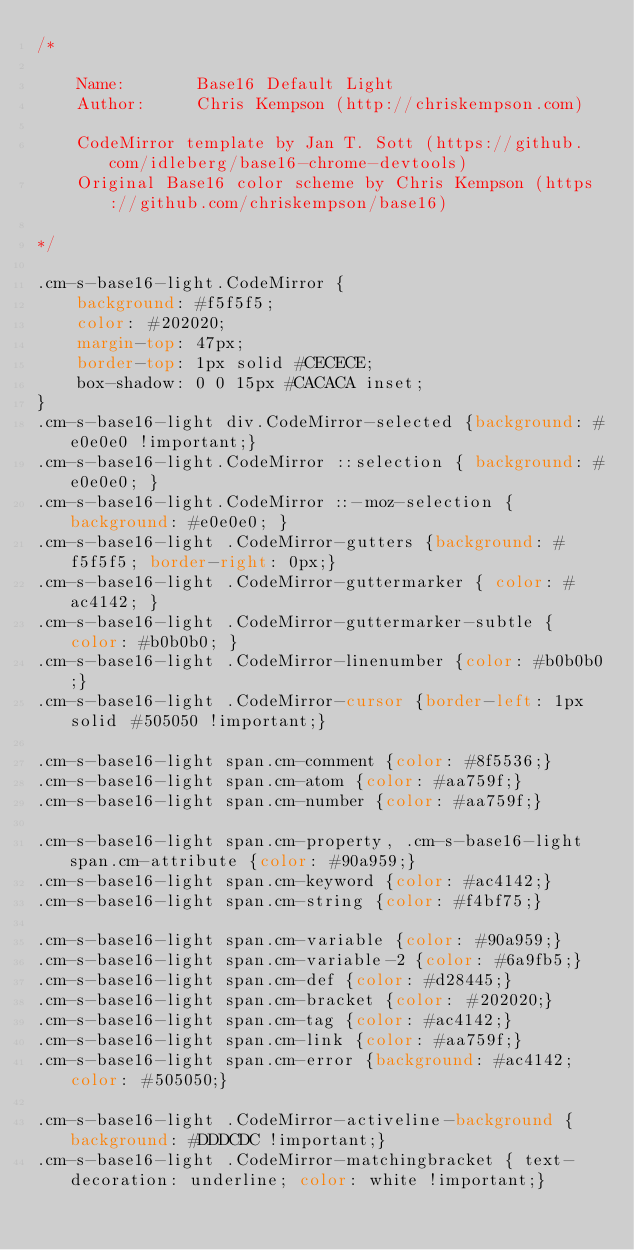<code> <loc_0><loc_0><loc_500><loc_500><_CSS_>/*

    Name:       Base16 Default Light
    Author:     Chris Kempson (http://chriskempson.com)

    CodeMirror template by Jan T. Sott (https://github.com/idleberg/base16-chrome-devtools)
    Original Base16 color scheme by Chris Kempson (https://github.com/chriskempson/base16)

*/

.cm-s-base16-light.CodeMirror {
    background: #f5f5f5;
    color: #202020;
    margin-top: 47px;
    border-top: 1px solid #CECECE;
    box-shadow: 0 0 15px #CACACA inset;
}
.cm-s-base16-light div.CodeMirror-selected {background: #e0e0e0 !important;}
.cm-s-base16-light.CodeMirror ::selection { background: #e0e0e0; }
.cm-s-base16-light.CodeMirror ::-moz-selection { background: #e0e0e0; }
.cm-s-base16-light .CodeMirror-gutters {background: #f5f5f5; border-right: 0px;}
.cm-s-base16-light .CodeMirror-guttermarker { color: #ac4142; }
.cm-s-base16-light .CodeMirror-guttermarker-subtle { color: #b0b0b0; }
.cm-s-base16-light .CodeMirror-linenumber {color: #b0b0b0;}
.cm-s-base16-light .CodeMirror-cursor {border-left: 1px solid #505050 !important;}

.cm-s-base16-light span.cm-comment {color: #8f5536;}
.cm-s-base16-light span.cm-atom {color: #aa759f;}
.cm-s-base16-light span.cm-number {color: #aa759f;}

.cm-s-base16-light span.cm-property, .cm-s-base16-light span.cm-attribute {color: #90a959;}
.cm-s-base16-light span.cm-keyword {color: #ac4142;}
.cm-s-base16-light span.cm-string {color: #f4bf75;}

.cm-s-base16-light span.cm-variable {color: #90a959;}
.cm-s-base16-light span.cm-variable-2 {color: #6a9fb5;}
.cm-s-base16-light span.cm-def {color: #d28445;}
.cm-s-base16-light span.cm-bracket {color: #202020;}
.cm-s-base16-light span.cm-tag {color: #ac4142;}
.cm-s-base16-light span.cm-link {color: #aa759f;}
.cm-s-base16-light span.cm-error {background: #ac4142; color: #505050;}

.cm-s-base16-light .CodeMirror-activeline-background {background: #DDDCDC !important;}
.cm-s-base16-light .CodeMirror-matchingbracket { text-decoration: underline; color: white !important;}
</code> 